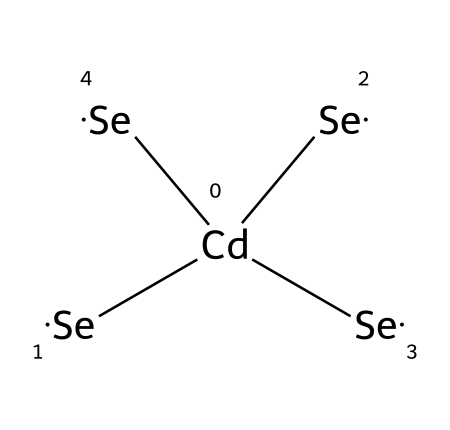What is the central atom in this chemical structure? The chemical structure shows that cadmium is represented by the symbol [Cd], indicating it is the central atom of the cadmium selenide quantum dots.
Answer: cadmium How many selenium atoms are present in this molecule? In the SMILES representation, there are four instances of the selenium symbol [Se], indicating that there are four selenium atoms connected to the cadmium atom.
Answer: four What is the total number of atoms in this structure? The molecule consists of one cadmium atom and four selenium atoms, adding up to a total of five atoms.
Answer: five What type of crystal structure do cadmium selenide quantum dots typically adopt? Cadmium selenide quantum dots usually crystallize in a zinc blende structure, which is a face-centered cubic arrangement common for this compound.
Answer: zinc blende What kind of bonding is predominantly found in cadmium selenide quantum dots? Cadmium selenide features ionic bonding between cadmium and selenium due to the transfer of electrons from cadmium to selenium, leading to the formation of charged ions that attract each other.
Answer: ionic bonding What is the significance of quantum dots in electronics? Quantum dots are significant in electronics due to their size-tunable optical and electronic properties, which allow for applications in displays, solar cells, and other electronic devices.
Answer: size-tunable properties 